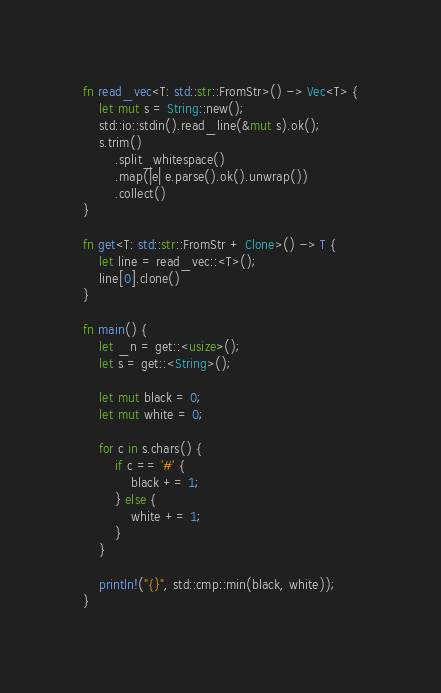<code> <loc_0><loc_0><loc_500><loc_500><_Rust_>fn read_vec<T: std::str::FromStr>() -> Vec<T> {
    let mut s = String::new();
    std::io::stdin().read_line(&mut s).ok();
    s.trim()
        .split_whitespace()
        .map(|e| e.parse().ok().unwrap())
        .collect()
}

fn get<T: std::str::FromStr + Clone>() -> T {
    let line = read_vec::<T>();
    line[0].clone()
}

fn main() {
    let _n = get::<usize>();
    let s = get::<String>();

    let mut black = 0;
    let mut white = 0;

    for c in s.chars() {
        if c == '#' {
            black += 1;
        } else {
            white += 1;
        }
    }

    println!("{}", std::cmp::min(black, white));
}
</code> 